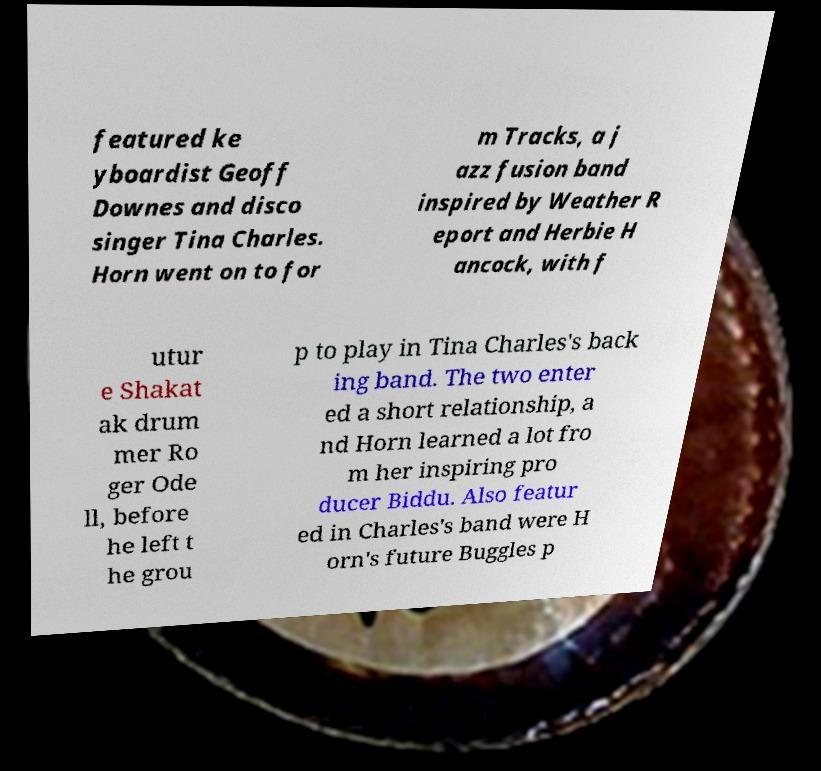Could you extract and type out the text from this image? featured ke yboardist Geoff Downes and disco singer Tina Charles. Horn went on to for m Tracks, a j azz fusion band inspired by Weather R eport and Herbie H ancock, with f utur e Shakat ak drum mer Ro ger Ode ll, before he left t he grou p to play in Tina Charles's back ing band. The two enter ed a short relationship, a nd Horn learned a lot fro m her inspiring pro ducer Biddu. Also featur ed in Charles's band were H orn's future Buggles p 